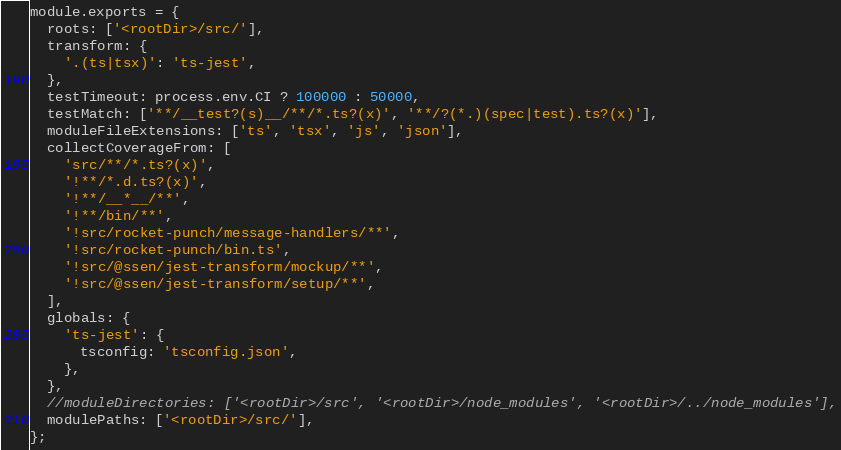<code> <loc_0><loc_0><loc_500><loc_500><_JavaScript_>module.exports = {
  roots: ['<rootDir>/src/'],
  transform: {
    '.(ts|tsx)': 'ts-jest',
  },
  testTimeout: process.env.CI ? 100000 : 50000,
  testMatch: ['**/__test?(s)__/**/*.ts?(x)', '**/?(*.)(spec|test).ts?(x)'],
  moduleFileExtensions: ['ts', 'tsx', 'js', 'json'],
  collectCoverageFrom: [
    'src/**/*.ts?(x)',
    '!**/*.d.ts?(x)',
    '!**/__*__/**',
    '!**/bin/**',
    '!src/rocket-punch/message-handlers/**',
    '!src/rocket-punch/bin.ts',
    '!src/@ssen/jest-transform/mockup/**',
    '!src/@ssen/jest-transform/setup/**',
  ],
  globals: {
    'ts-jest': {
      tsconfig: 'tsconfig.json',
    },
  },
  //moduleDirectories: ['<rootDir>/src', '<rootDir>/node_modules', '<rootDir>/../node_modules'],
  modulePaths: ['<rootDir>/src/'],
};
</code> 